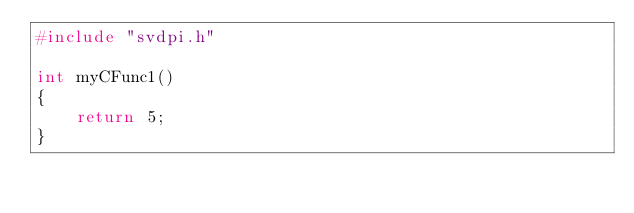Convert code to text. <code><loc_0><loc_0><loc_500><loc_500><_C_>#include "svdpi.h"

int myCFunc1()
{
    return 5;
}
</code> 